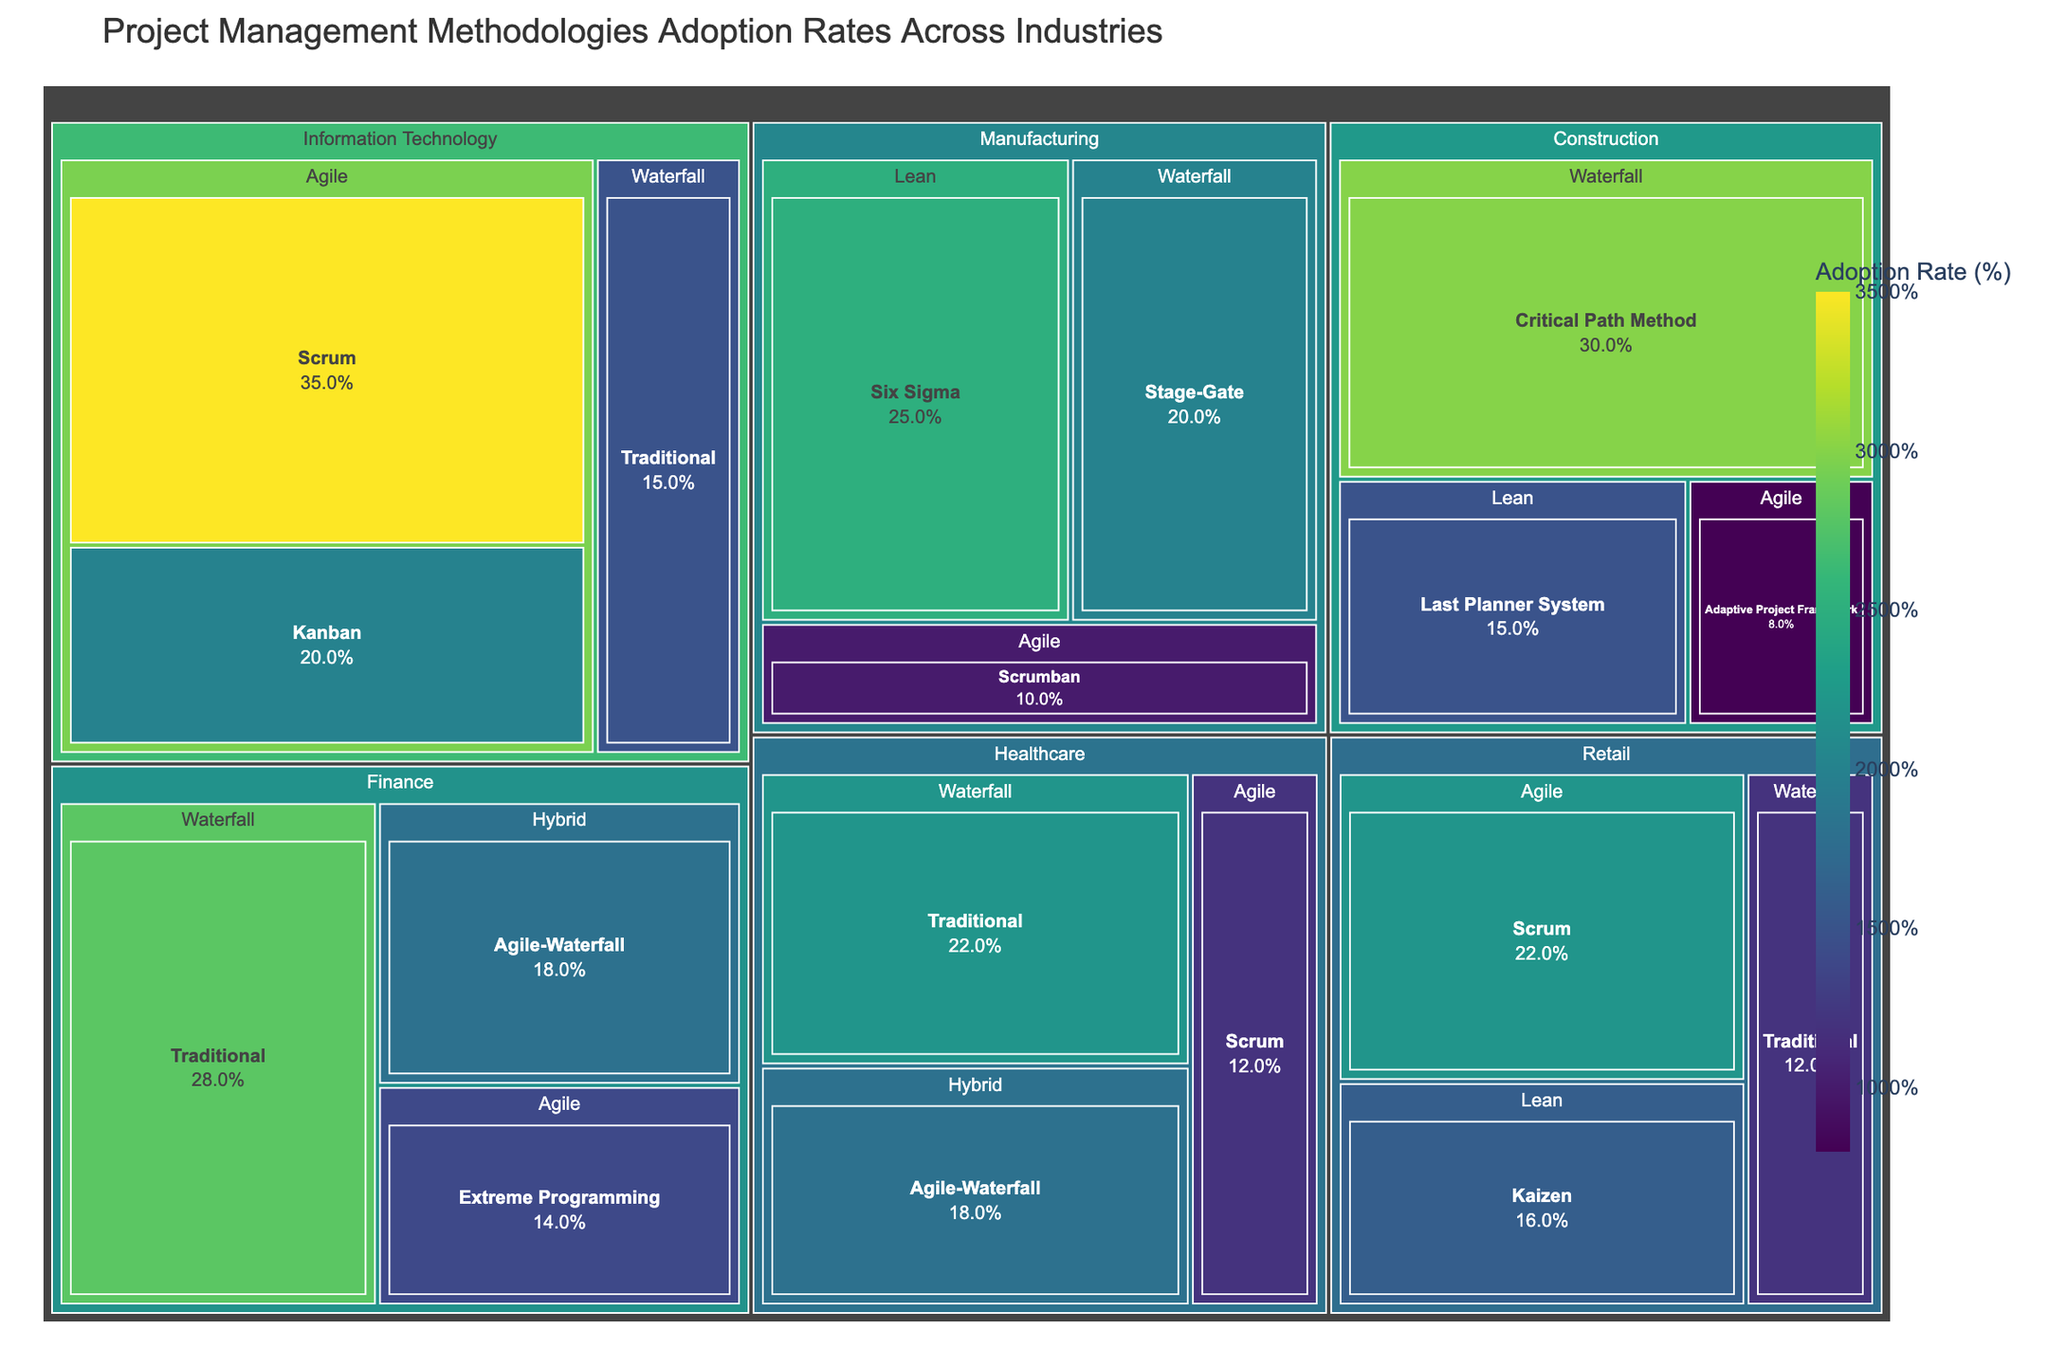What's the title of the treemap? The title is usually located at the top of the figure. By referring to the top of the treemap, we can see the given title.
Answer: Project Management Methodologies Adoption Rates Across Industries Which industry has the highest adoption rate for a single methodology subtype? By looking at the largest blocks within each methodology subtype, we can see that Information Technology - Agile - Scrum holds the highest adoption rate.
Answer: Information Technology - Agile - Scrum How does the adoption rate of Agile methodologies in Information Technology compare to Waterfall methodologies in the same industry? Summing up the adoption rates for Agile methodologies (Scrum + Kanban) gives 35 + 20 = 55. For Waterfall, the adoption rate is 15. By comparing these, we see that Agile has a significantly higher adoption rate.
Answer: Agile: 55%, Waterfall: 15% What is the combined adoption rate for the Waterfall methodology in all industries? The Waterfall approach has multiple subtypes across industries: Information Technology - 15%, Manufacturing - 20%, Healthcare - 22%, Construction - 30%, Finance - 28%, Retail - 12%. Adding these gives 15 + 20 + 22 + 30 + 28 + 12 = 127.
Answer: 127% Which methodology subtype has the lowest adoption rate overall? By scanning the treemap for the smallest block, we identify that Construction - Agile - Adaptive Project Framework has the lowest rate of 8%.
Answer: Construction - Agile - Adaptive Project Framework - 8% What is the difference in adoption rates between Healthcare using Agile Scrum and Finance using Agile Extreme Programming? Adoption rate for Healthcare - Agile - Scrum is 12%. For Finance - Agile - Extreme Programming, it's 14%. The difference is 14 - 12 = 2.
Answer: 2% Is the Hybrid methodology equally adopted in both Healthcare and Finance? By identifying the blocks for Hybrid methodology in Healthcare and Finance, each block has an adoption rate of 18%, indicating they are equal.
Answer: Yes, both are 18% What's the average adoption rate of Lean methodologies across all industries? Lean methodologies include Manufacturing - Six Sigma (25%), Construction - Last Planner System (15%), and Retail - Kaizen (16%). The average is calculated as (25 + 15 + 16) / 3 = 18.67%.
Answer: 18.67% Which industry has the highest number of different subtype methodologies adopted? By counting the number of subtype blocks within each industry, we find Information Technology has the most varied methodologies: Scrum, Kanban, Traditional (Waterfall).
Answer: Information Technology (3 subtypes) Which industry primarily uses the Waterfall - Critical Path Method? By identifying the block related to Waterfall - Critical Path Method, we see it is solely in the Construction industry with an adoption rate of 30%.
Answer: Construction 